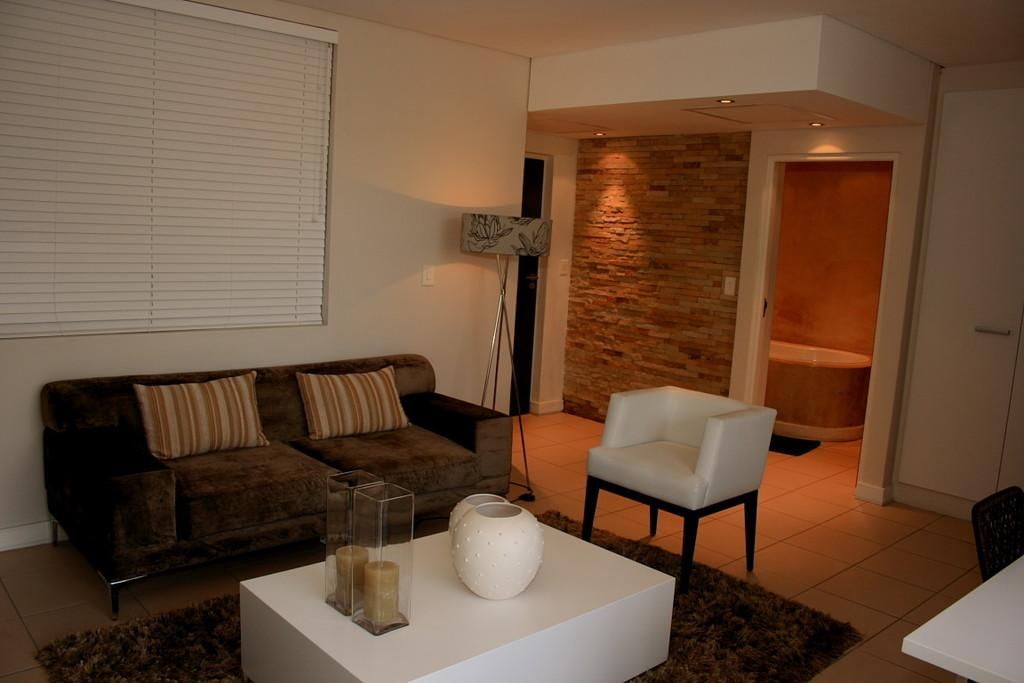What type of room is depicted in the image? There is a living room in the image. What furniture can be seen in the living room? There is a sofa and a table in the living room. What is used to provide illumination in the living room? There are lights in the living room. What type of string is being used to hold up the clock in the image? There is no clock present in the image, so it is not possible to determine what type of string might be used to hold it up. 